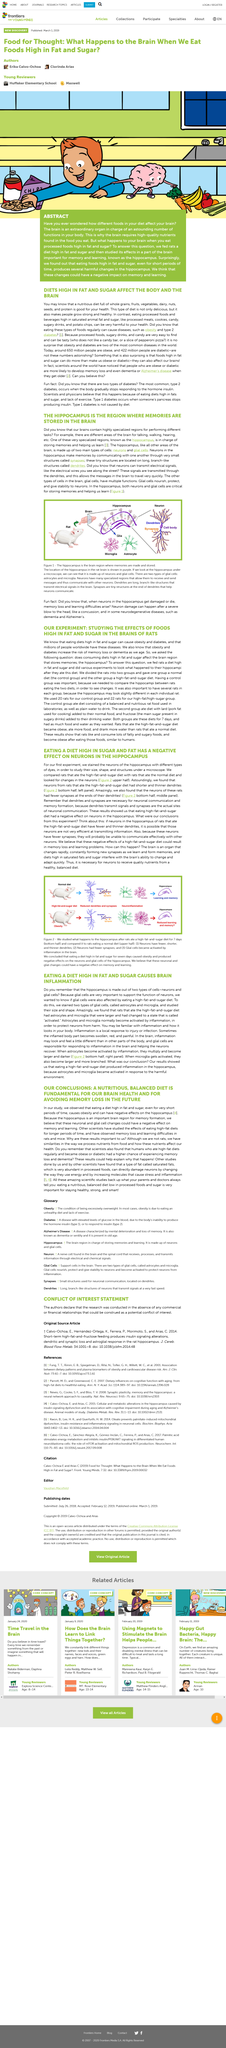Give some essential details in this illustration. Eating food high in fat and sugar can negatively affect the hippocampus, a region of the brain responsible for memory and learning. Memories communicate with each other through dendrites, which are tiny structures in the brain. Hippocampuses are composed of both neurons and glial cells. The brain requires a significant amount of nutrients due to its critical role in regulating various bodily functions. As such, it is essential to consume nutrient-dense foods rather than junk food to ensure optimal brain function and overall health. The hippocampus is a region in the brain where memories are stored. 